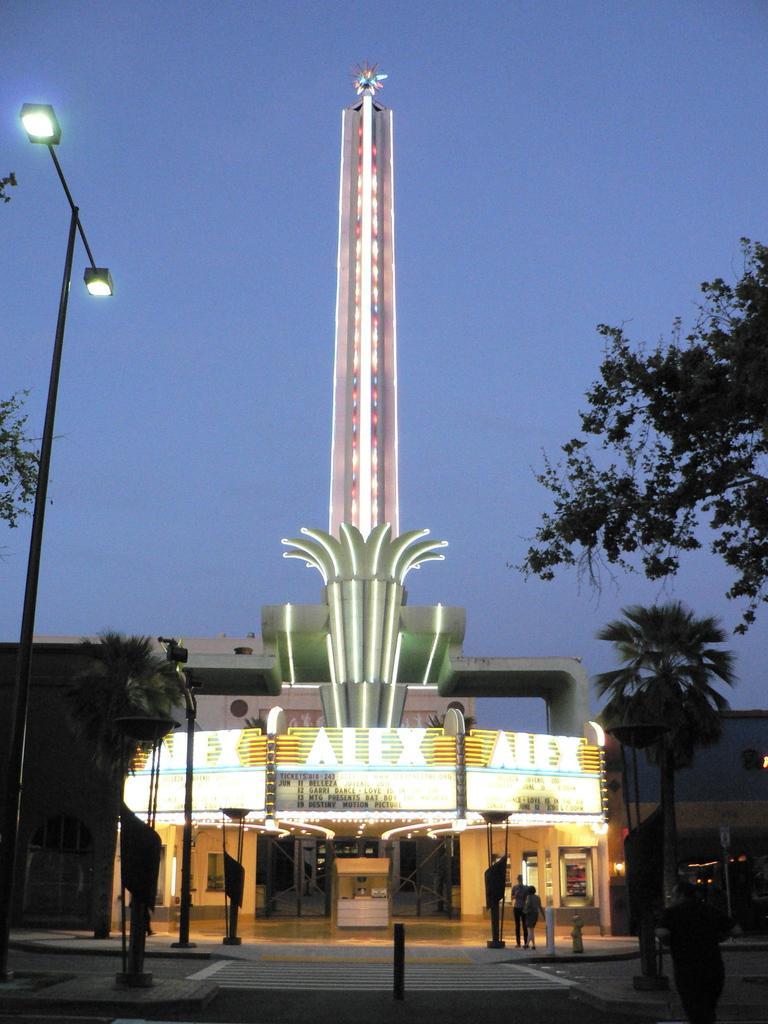Describe this image in one or two sentences. In the image I can see a building like place to which there are some lights and around there are some poles, trees and people. 